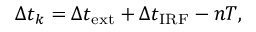Convert formula to latex. <formula><loc_0><loc_0><loc_500><loc_500>\Delta t _ { k } = \Delta t _ { e x t } + \Delta t _ { I R F } - n T ,</formula> 